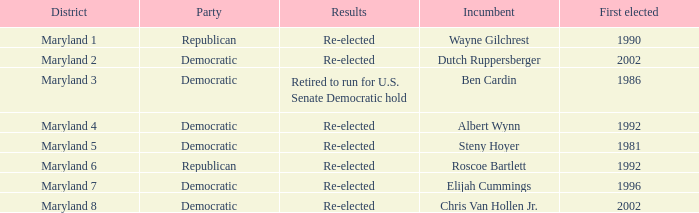What are the results of the incumbent who was first elected in 1996? Re-elected. 